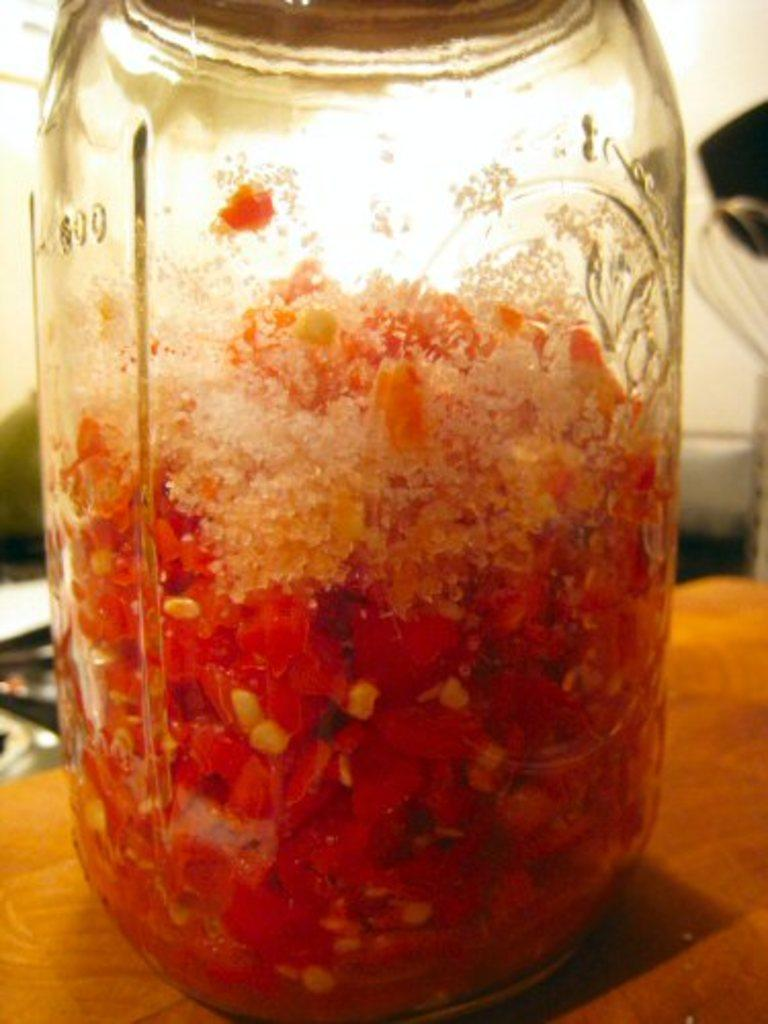What can be found in the image related to planting or gardening? There are seeds in the image. What type of container is holding food items in the image? There is a jar on a wooden surface that contains food items. What is the surface that the jar is placed on? The jar is on a wooden surface. What kitchen utensil can be seen in the background of the image? There is a whisk in the background of the image. Are there any other objects visible in the background of the image? Yes, there are other objects in the background of the image. How many geese are walking peacefully in the image? There are no geese present in the image. What type of bit is used to eat the food items in the jar? The image does not show any utensils being used to eat the food items in the jar. 